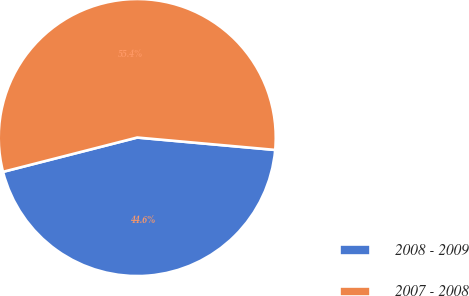<chart> <loc_0><loc_0><loc_500><loc_500><pie_chart><fcel>2008 - 2009<fcel>2007 - 2008<nl><fcel>44.59%<fcel>55.41%<nl></chart> 